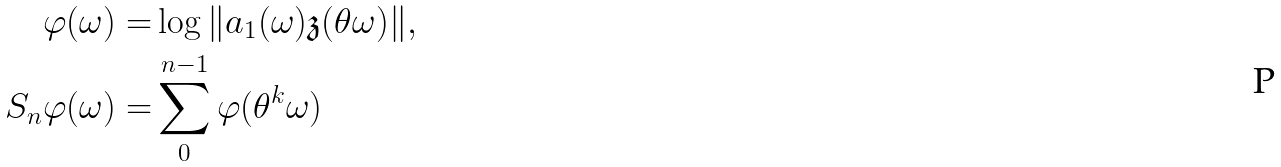Convert formula to latex. <formula><loc_0><loc_0><loc_500><loc_500>\varphi ( \omega ) = & \log \| a _ { 1 } ( \omega ) \mathfrak z ( \theta \omega ) \| , \\ S _ { n } \varphi ( \omega ) = & \sum _ { 0 } ^ { n - 1 } \varphi ( \theta ^ { k } \omega )</formula> 